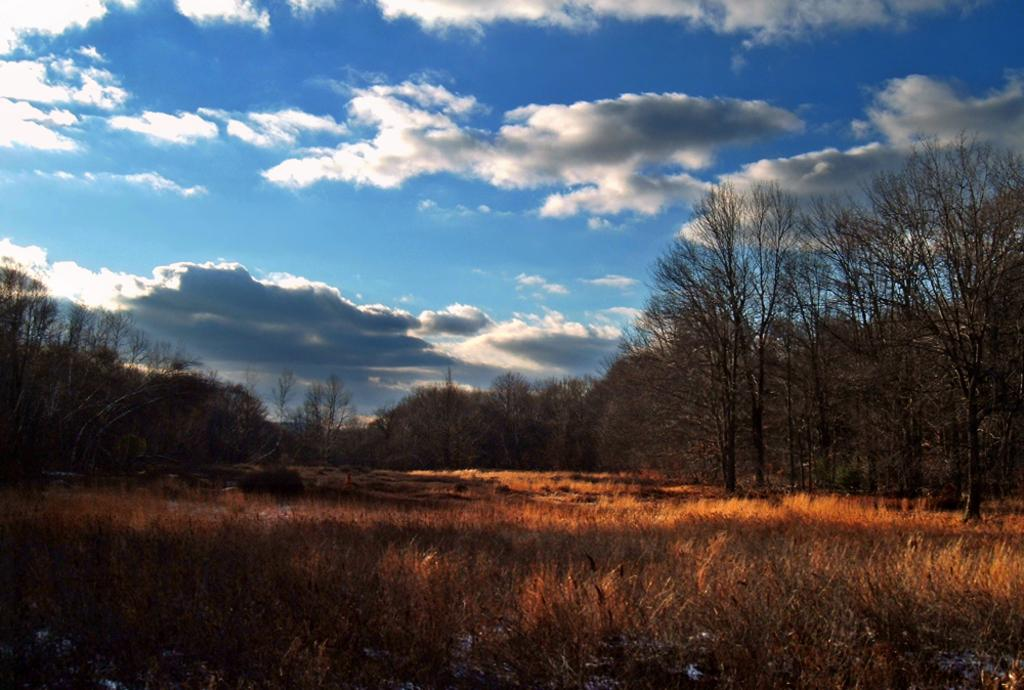What type of vegetation is present in the image? There is grass and trees in the image. What color is the sky in the image? The sky is blue in the image. Can you describe the setting of the image? The image may have been taken in a forest, given the presence of grass and trees. How many eyes can be seen on the canvas in the image? There is no canvas or eyes present in the image. What type of whip is used to create the patterns in the grass in the image? There are no patterns or whips present in the image; it features grass, trees, and a blue sky. 